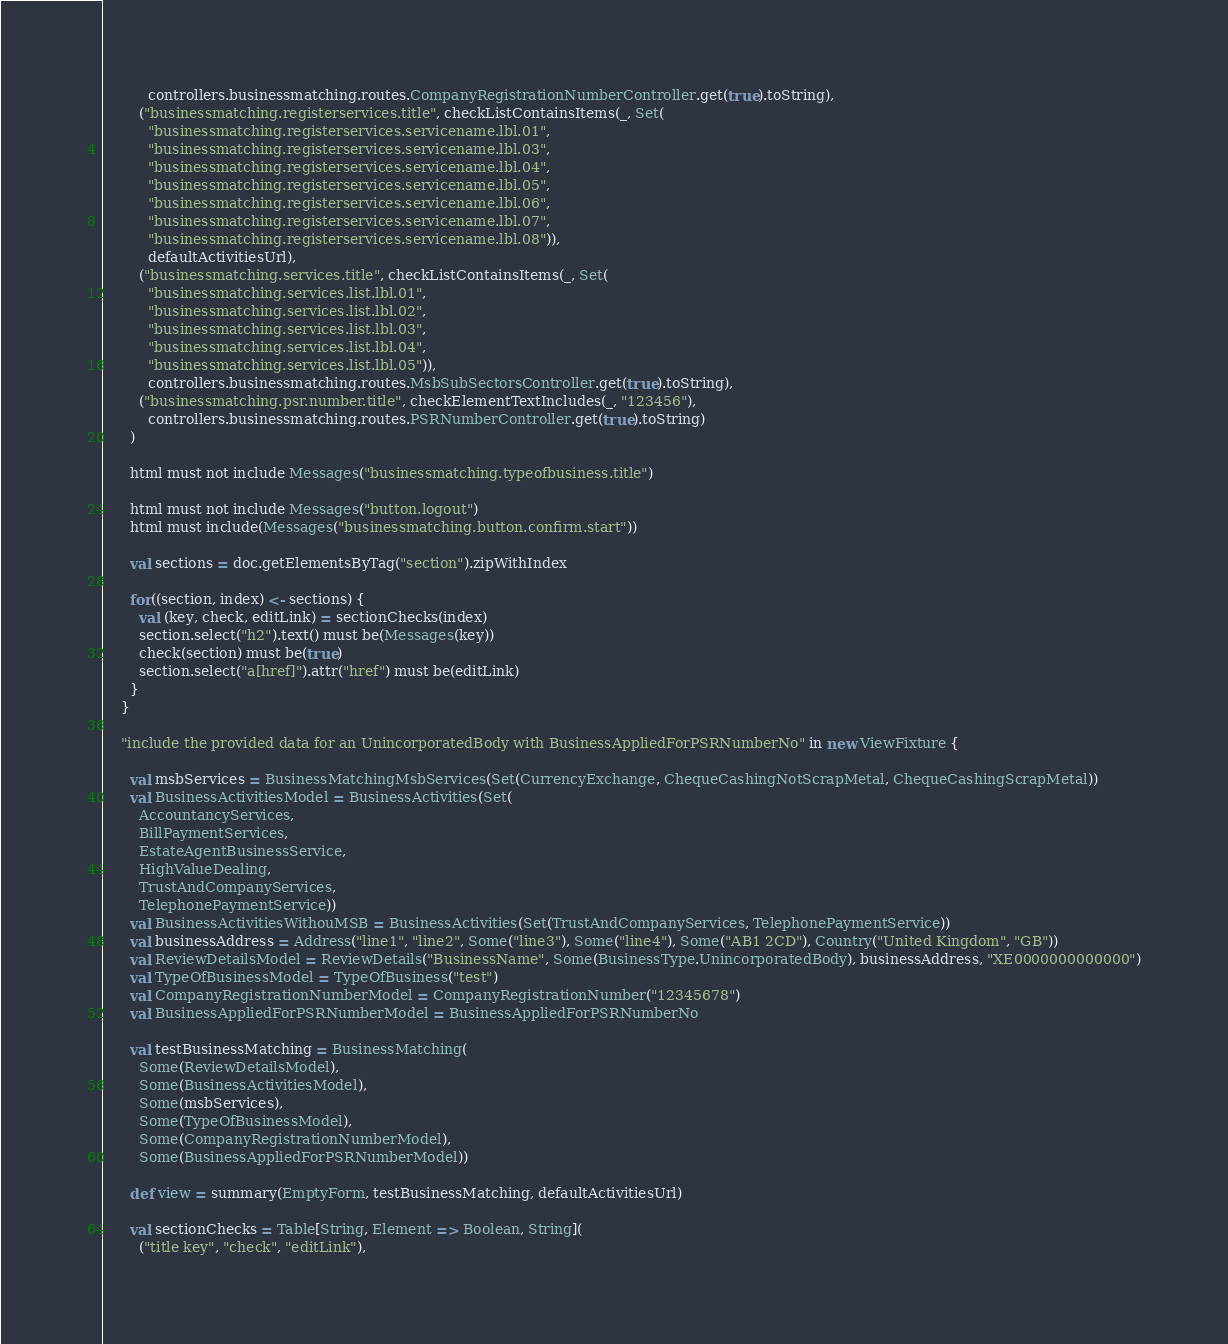Convert code to text. <code><loc_0><loc_0><loc_500><loc_500><_Scala_>          controllers.businessmatching.routes.CompanyRegistrationNumberController.get(true).toString),
        ("businessmatching.registerservices.title", checkListContainsItems(_, Set(
          "businessmatching.registerservices.servicename.lbl.01",
          "businessmatching.registerservices.servicename.lbl.03",
          "businessmatching.registerservices.servicename.lbl.04",
          "businessmatching.registerservices.servicename.lbl.05",
          "businessmatching.registerservices.servicename.lbl.06",
          "businessmatching.registerservices.servicename.lbl.07",
          "businessmatching.registerservices.servicename.lbl.08")),
          defaultActivitiesUrl),
        ("businessmatching.services.title", checkListContainsItems(_, Set(
          "businessmatching.services.list.lbl.01",
          "businessmatching.services.list.lbl.02",
          "businessmatching.services.list.lbl.03",
          "businessmatching.services.list.lbl.04",
          "businessmatching.services.list.lbl.05")),
          controllers.businessmatching.routes.MsbSubSectorsController.get(true).toString),
        ("businessmatching.psr.number.title", checkElementTextIncludes(_, "123456"),
          controllers.businessmatching.routes.PSRNumberController.get(true).toString)
      )

      html must not include Messages("businessmatching.typeofbusiness.title")

      html must not include Messages("button.logout")
      html must include(Messages("businessmatching.button.confirm.start"))

      val sections = doc.getElementsByTag("section").zipWithIndex

      for((section, index) <- sections) {
        val (key, check, editLink) = sectionChecks(index)
        section.select("h2").text() must be(Messages(key))
        check(section) must be(true)
        section.select("a[href]").attr("href") must be(editLink)
      }
    }

    "include the provided data for an UnincorporatedBody with BusinessAppliedForPSRNumberNo" in new ViewFixture {

      val msbServices = BusinessMatchingMsbServices(Set(CurrencyExchange, ChequeCashingNotScrapMetal, ChequeCashingScrapMetal))
      val BusinessActivitiesModel = BusinessActivities(Set(
        AccountancyServices,
        BillPaymentServices,
        EstateAgentBusinessService,
        HighValueDealing,
        TrustAndCompanyServices,
        TelephonePaymentService))
      val BusinessActivitiesWithouMSB = BusinessActivities(Set(TrustAndCompanyServices, TelephonePaymentService))
      val businessAddress = Address("line1", "line2", Some("line3"), Some("line4"), Some("AB1 2CD"), Country("United Kingdom", "GB"))
      val ReviewDetailsModel = ReviewDetails("BusinessName", Some(BusinessType.UnincorporatedBody), businessAddress, "XE0000000000000")
      val TypeOfBusinessModel = TypeOfBusiness("test")
      val CompanyRegistrationNumberModel = CompanyRegistrationNumber("12345678")
      val BusinessAppliedForPSRNumberModel = BusinessAppliedForPSRNumberNo

      val testBusinessMatching = BusinessMatching(
        Some(ReviewDetailsModel),
        Some(BusinessActivitiesModel),
        Some(msbServices),
        Some(TypeOfBusinessModel),
        Some(CompanyRegistrationNumberModel),
        Some(BusinessAppliedForPSRNumberModel))

      def view = summary(EmptyForm, testBusinessMatching, defaultActivitiesUrl)

      val sectionChecks = Table[String, Element => Boolean, String](
        ("title key", "check", "editLink"),</code> 